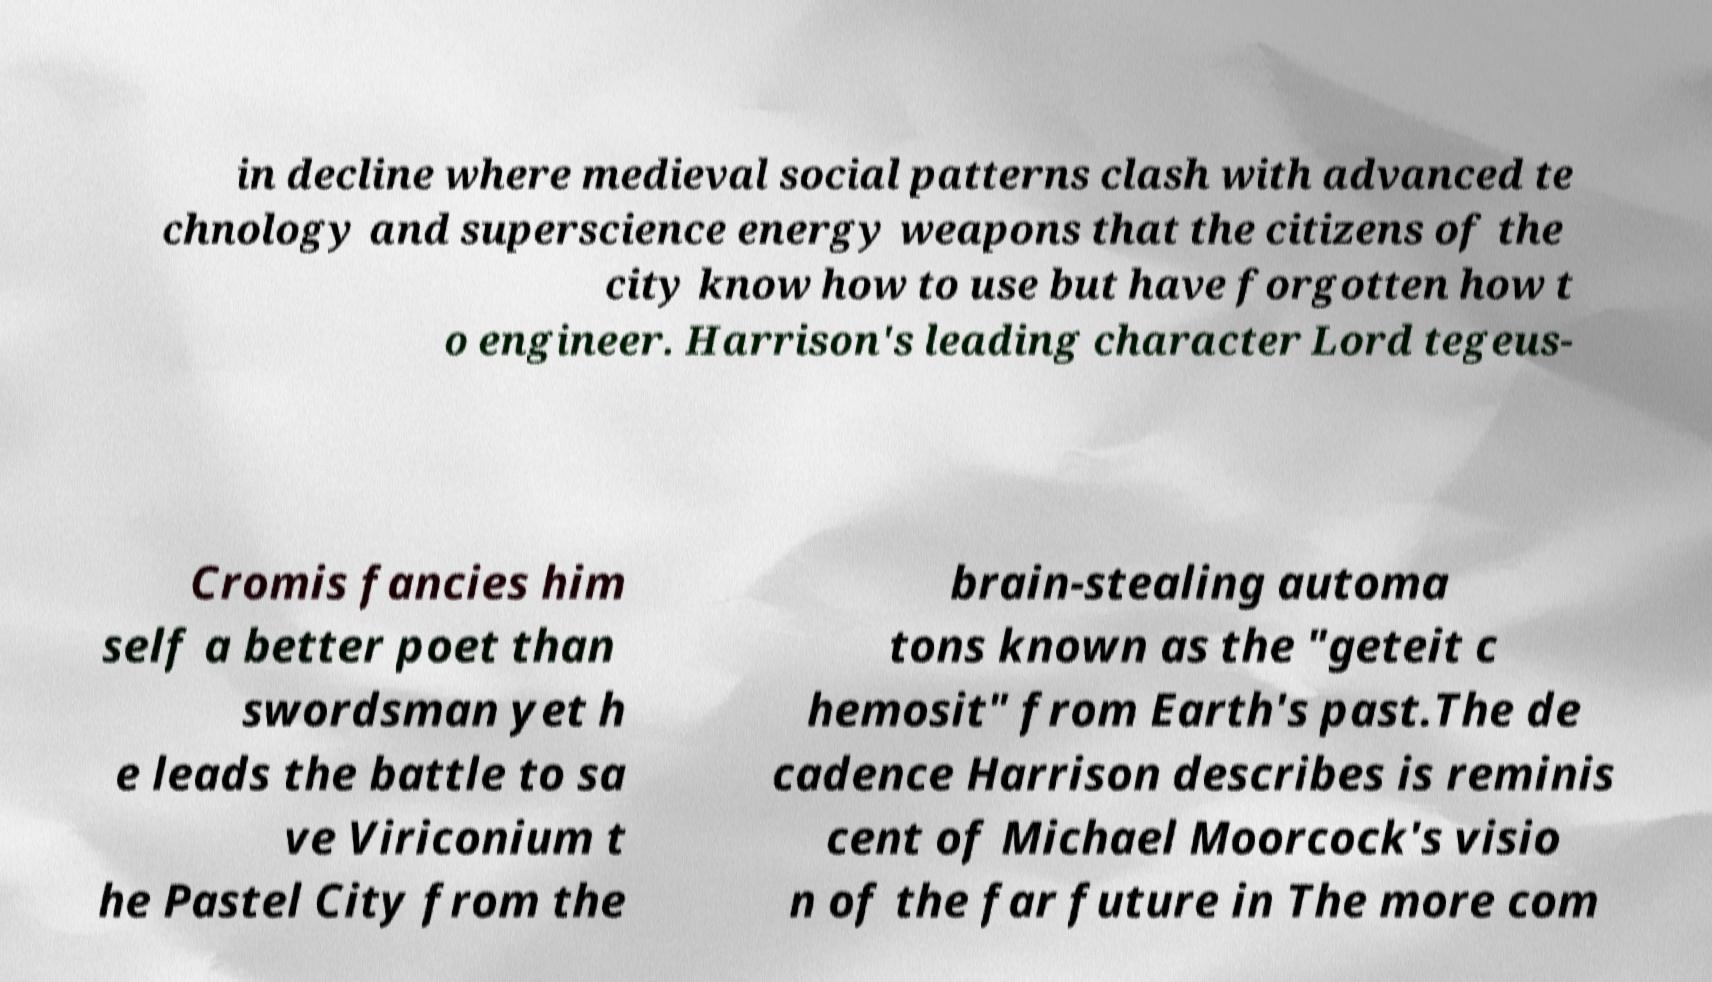What messages or text are displayed in this image? I need them in a readable, typed format. in decline where medieval social patterns clash with advanced te chnology and superscience energy weapons that the citizens of the city know how to use but have forgotten how t o engineer. Harrison's leading character Lord tegeus- Cromis fancies him self a better poet than swordsman yet h e leads the battle to sa ve Viriconium t he Pastel City from the brain-stealing automa tons known as the "geteit c hemosit" from Earth's past.The de cadence Harrison describes is reminis cent of Michael Moorcock's visio n of the far future in The more com 